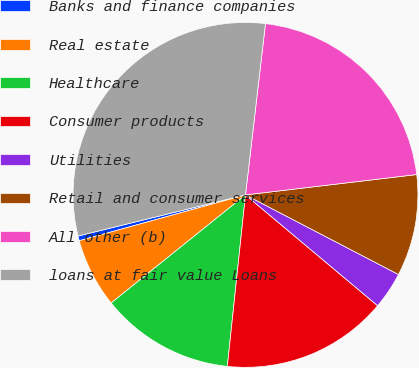<chart> <loc_0><loc_0><loc_500><loc_500><pie_chart><fcel>Banks and finance companies<fcel>Real estate<fcel>Healthcare<fcel>Consumer products<fcel>Utilities<fcel>Retail and consumer services<fcel>All other (b)<fcel>loans at fair value Loans<nl><fcel>0.45%<fcel>6.5%<fcel>12.54%<fcel>15.57%<fcel>3.47%<fcel>9.52%<fcel>21.27%<fcel>30.68%<nl></chart> 